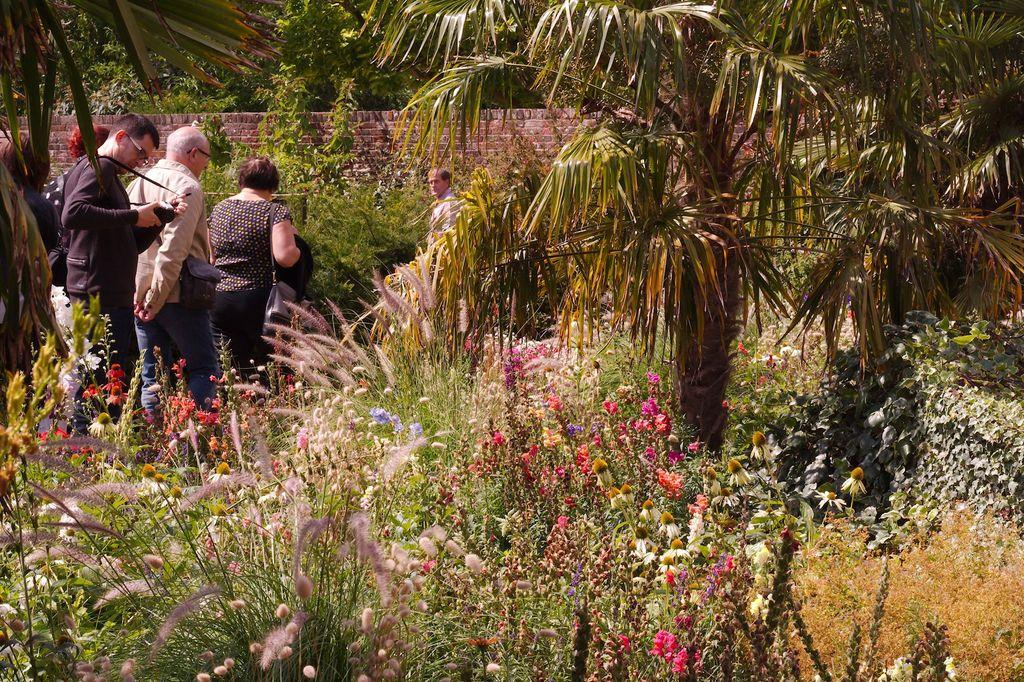What type of vegetation can be seen in the image? There are plants and trees in the image. What is happening in the background of the image? There are people walking in the background of the image. What architectural feature is visible in the background of the image? There is a wall visible in the background of the image. What type of cheese is being used to stitch the fan in the image? There is no cheese, stitching, or fan present in the image. 